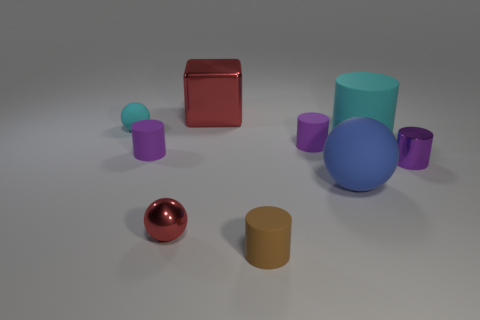What shape is the purple thing left of the cylinder that is in front of the shiny sphere?
Give a very brief answer. Cylinder. Is there any other thing that is the same color as the cube?
Provide a short and direct response. Yes. There is a red metallic thing that is behind the large matte ball; what is its shape?
Provide a short and direct response. Cube. There is a tiny matte thing that is on the left side of the brown rubber thing and to the right of the small cyan sphere; what shape is it?
Your answer should be very brief. Cylinder. What number of cyan objects are either tiny blocks or tiny shiny cylinders?
Keep it short and to the point. 0. There is a small ball right of the small matte sphere; is it the same color as the large block?
Offer a terse response. Yes. There is a rubber object right of the large matte thing that is in front of the large cyan thing; what is its size?
Keep it short and to the point. Large. There is a cyan sphere that is the same size as the metallic cylinder; what material is it?
Your answer should be compact. Rubber. What number of other objects are the same size as the cyan sphere?
Ensure brevity in your answer.  5. What number of balls are blue rubber objects or brown things?
Your answer should be very brief. 1. 